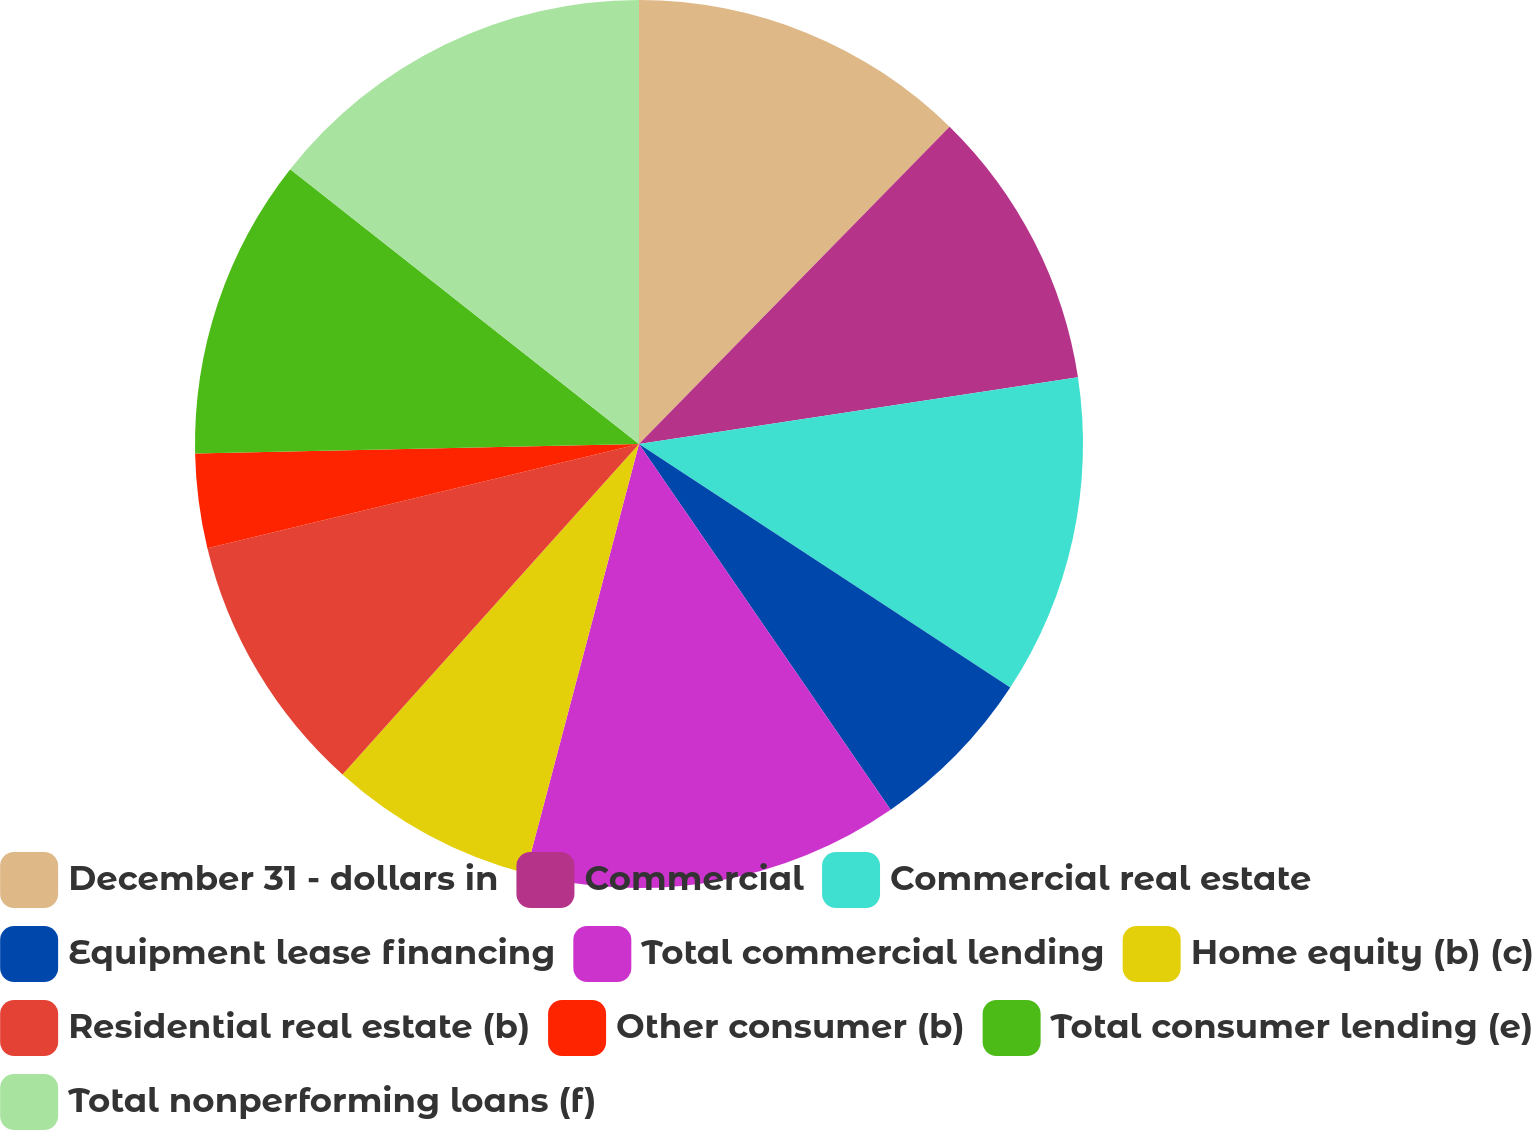<chart> <loc_0><loc_0><loc_500><loc_500><pie_chart><fcel>December 31 - dollars in<fcel>Commercial<fcel>Commercial real estate<fcel>Equipment lease financing<fcel>Total commercial lending<fcel>Home equity (b) (c)<fcel>Residential real estate (b)<fcel>Other consumer (b)<fcel>Total consumer lending (e)<fcel>Total nonperforming loans (f)<nl><fcel>12.33%<fcel>10.27%<fcel>11.64%<fcel>6.17%<fcel>13.7%<fcel>7.53%<fcel>9.59%<fcel>3.43%<fcel>10.96%<fcel>14.38%<nl></chart> 